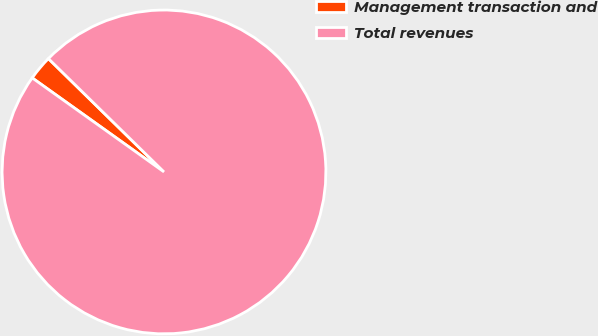<chart> <loc_0><loc_0><loc_500><loc_500><pie_chart><fcel>Management transaction and<fcel>Total revenues<nl><fcel>2.48%<fcel>97.52%<nl></chart> 